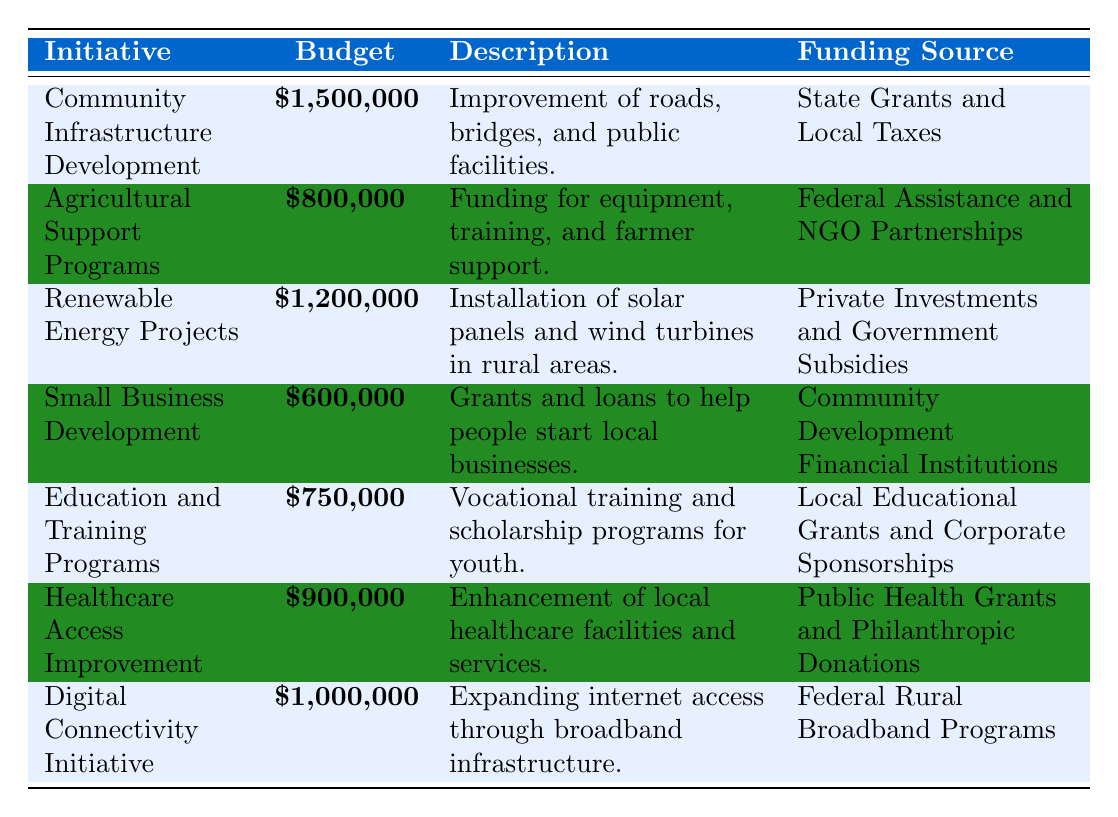What is the highest budget allocation in the table? The table lists various initiatives with their respective budget allocations. Scanning through the budget values, the highest is for "Community Infrastructure Development," which has a budget of \$1,500,000.
Answer: \$1,500,000 Which initiative has the lowest budget? The table clearly indicates the budget amounts for each initiative. The initiative with the lowest budget is "Small Business Development," with an allocation of \$600,000.
Answer: \$600,000 How much total budget is allocated for Renewable Energy Projects and Digital Connectivity Initiative combined? To find the total for both initiatives, we first identify their budget amounts, which are \$1,200,000 for Renewable Energy Projects and \$1,000,000 for Digital Connectivity Initiative. Summing these gives \$1,200,000 + \$1,000,000 = \$2,200,000.
Answer: \$2,200,000 Is the funding source for the Healthcare Access Improvement initiative provided by private investments? The funding source for "Healthcare Access Improvement" is noted as "Public Health Grants and Philanthropic Donations," which are not private investments. Thus, the statement is false.
Answer: No What is the average budget allocation for the initiatives listed in the table? There are 7 initiatives listed in the table with the corresponding budgets: \$1,500,000, \$800,000, \$1,200,000, \$600,000, \$750,000, \$900,000, and \$1,000,000. Adding these gives \$1,500,000 + \$800,000 + \$1,200,000 + \$600,000 + \$750,000 + \$900,000 + \$1,000,000 = \$6,750,000. Dividing this total by the number of initiatives (7) gives an average of \$6,750,000 / 7 = \$964,285.71 (approximately).
Answer: \$964,285.71 If the budget for Agricultural Support Programs were increased by \$200,000, what would the new total budget allocation be? The current budget for Agricultural Support Programs is \$800,000. If this budget is increased by \$200,000, the new budget would be \$800,000 + \$200,000 = \$1,000,000. To find the new total budget allocation for all initiatives, we calculate the total from the original budgets (\$6,750,000) plus the increase, leading to \$6,750,000 + \$200,000 = \$6,950,000.
Answer: \$6,950,000 What percentage of the total budget is allocated for Education and Training Programs? The budget for "Education and Training Programs" is \$750,000. First, we find the total budget from all initiatives, which is \$6,750,000. The percentage is calculated by dividing the Education budget by the total budget and then multiplying by 100. Thus, (\$750,000 / \$6,750,000) × 100 = approximately 11.11%.
Answer: 11.11% 